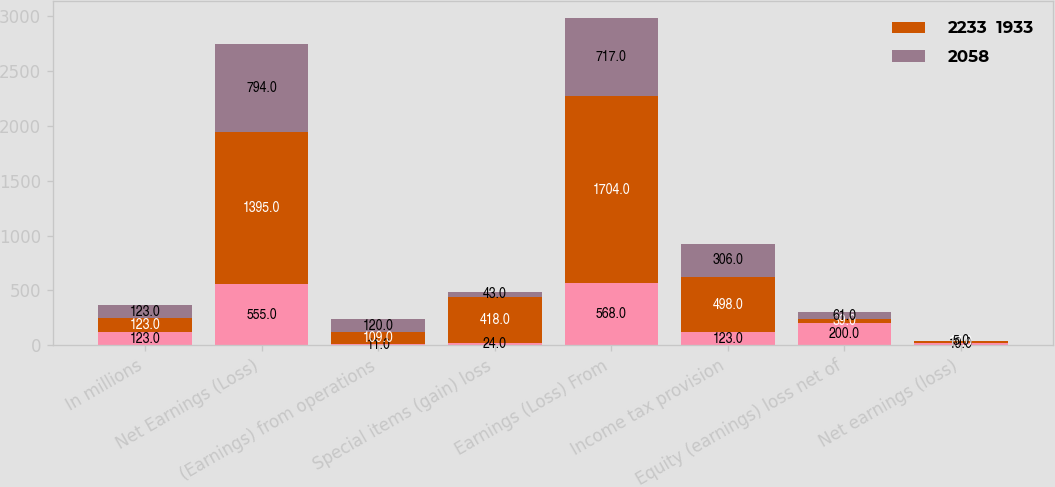Convert chart. <chart><loc_0><loc_0><loc_500><loc_500><stacked_bar_chart><ecel><fcel>In millions<fcel>Net Earnings (Loss)<fcel>(Earnings) from operations<fcel>Special items (gain) loss<fcel>Earnings (Loss) From<fcel>Income tax provision<fcel>Equity (earnings) loss net of<fcel>Net earnings (loss)<nl><fcel>nan<fcel>123<fcel>555<fcel>11<fcel>24<fcel>568<fcel>123<fcel>200<fcel>19<nl><fcel>2233  1933<fcel>123<fcel>1395<fcel>109<fcel>418<fcel>1704<fcel>498<fcel>39<fcel>17<nl><fcel>2058<fcel>123<fcel>794<fcel>120<fcel>43<fcel>717<fcel>306<fcel>61<fcel>5<nl></chart> 